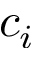Convert formula to latex. <formula><loc_0><loc_0><loc_500><loc_500>c _ { i }</formula> 